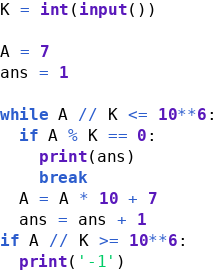Convert code to text. <code><loc_0><loc_0><loc_500><loc_500><_Python_>K = int(input())

A = 7
ans = 1

while A // K <= 10**6:
  if A % K == 0:
    print(ans)
    break
  A = A * 10 + 7
  ans = ans + 1
if A // K >= 10**6:
  print('-1')</code> 